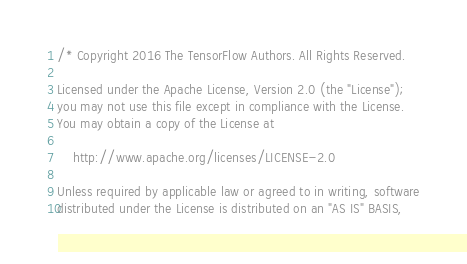Convert code to text. <code><loc_0><loc_0><loc_500><loc_500><_C_>/* Copyright 2016 The TensorFlow Authors. All Rights Reserved.

Licensed under the Apache License, Version 2.0 (the "License");
you may not use this file except in compliance with the License.
You may obtain a copy of the License at

    http://www.apache.org/licenses/LICENSE-2.0

Unless required by applicable law or agreed to in writing, software
distributed under the License is distributed on an "AS IS" BASIS,</code> 